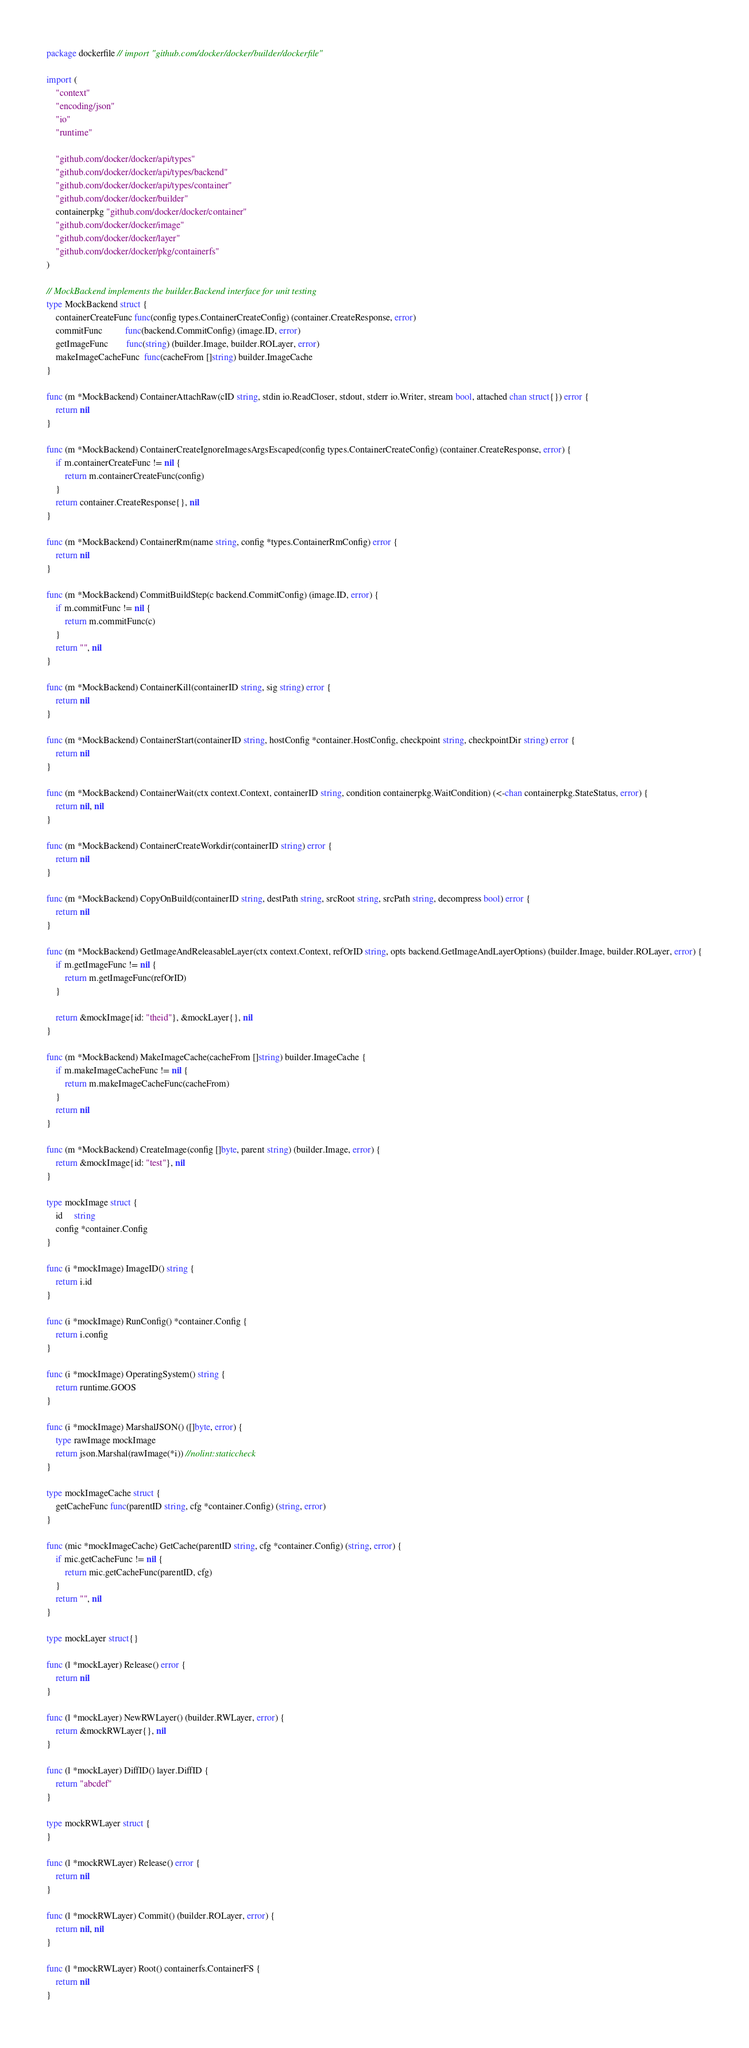<code> <loc_0><loc_0><loc_500><loc_500><_Go_>package dockerfile // import "github.com/docker/docker/builder/dockerfile"

import (
	"context"
	"encoding/json"
	"io"
	"runtime"

	"github.com/docker/docker/api/types"
	"github.com/docker/docker/api/types/backend"
	"github.com/docker/docker/api/types/container"
	"github.com/docker/docker/builder"
	containerpkg "github.com/docker/docker/container"
	"github.com/docker/docker/image"
	"github.com/docker/docker/layer"
	"github.com/docker/docker/pkg/containerfs"
)

// MockBackend implements the builder.Backend interface for unit testing
type MockBackend struct {
	containerCreateFunc func(config types.ContainerCreateConfig) (container.CreateResponse, error)
	commitFunc          func(backend.CommitConfig) (image.ID, error)
	getImageFunc        func(string) (builder.Image, builder.ROLayer, error)
	makeImageCacheFunc  func(cacheFrom []string) builder.ImageCache
}

func (m *MockBackend) ContainerAttachRaw(cID string, stdin io.ReadCloser, stdout, stderr io.Writer, stream bool, attached chan struct{}) error {
	return nil
}

func (m *MockBackend) ContainerCreateIgnoreImagesArgsEscaped(config types.ContainerCreateConfig) (container.CreateResponse, error) {
	if m.containerCreateFunc != nil {
		return m.containerCreateFunc(config)
	}
	return container.CreateResponse{}, nil
}

func (m *MockBackend) ContainerRm(name string, config *types.ContainerRmConfig) error {
	return nil
}

func (m *MockBackend) CommitBuildStep(c backend.CommitConfig) (image.ID, error) {
	if m.commitFunc != nil {
		return m.commitFunc(c)
	}
	return "", nil
}

func (m *MockBackend) ContainerKill(containerID string, sig string) error {
	return nil
}

func (m *MockBackend) ContainerStart(containerID string, hostConfig *container.HostConfig, checkpoint string, checkpointDir string) error {
	return nil
}

func (m *MockBackend) ContainerWait(ctx context.Context, containerID string, condition containerpkg.WaitCondition) (<-chan containerpkg.StateStatus, error) {
	return nil, nil
}

func (m *MockBackend) ContainerCreateWorkdir(containerID string) error {
	return nil
}

func (m *MockBackend) CopyOnBuild(containerID string, destPath string, srcRoot string, srcPath string, decompress bool) error {
	return nil
}

func (m *MockBackend) GetImageAndReleasableLayer(ctx context.Context, refOrID string, opts backend.GetImageAndLayerOptions) (builder.Image, builder.ROLayer, error) {
	if m.getImageFunc != nil {
		return m.getImageFunc(refOrID)
	}

	return &mockImage{id: "theid"}, &mockLayer{}, nil
}

func (m *MockBackend) MakeImageCache(cacheFrom []string) builder.ImageCache {
	if m.makeImageCacheFunc != nil {
		return m.makeImageCacheFunc(cacheFrom)
	}
	return nil
}

func (m *MockBackend) CreateImage(config []byte, parent string) (builder.Image, error) {
	return &mockImage{id: "test"}, nil
}

type mockImage struct {
	id     string
	config *container.Config
}

func (i *mockImage) ImageID() string {
	return i.id
}

func (i *mockImage) RunConfig() *container.Config {
	return i.config
}

func (i *mockImage) OperatingSystem() string {
	return runtime.GOOS
}

func (i *mockImage) MarshalJSON() ([]byte, error) {
	type rawImage mockImage
	return json.Marshal(rawImage(*i)) //nolint:staticcheck
}

type mockImageCache struct {
	getCacheFunc func(parentID string, cfg *container.Config) (string, error)
}

func (mic *mockImageCache) GetCache(parentID string, cfg *container.Config) (string, error) {
	if mic.getCacheFunc != nil {
		return mic.getCacheFunc(parentID, cfg)
	}
	return "", nil
}

type mockLayer struct{}

func (l *mockLayer) Release() error {
	return nil
}

func (l *mockLayer) NewRWLayer() (builder.RWLayer, error) {
	return &mockRWLayer{}, nil
}

func (l *mockLayer) DiffID() layer.DiffID {
	return "abcdef"
}

type mockRWLayer struct {
}

func (l *mockRWLayer) Release() error {
	return nil
}

func (l *mockRWLayer) Commit() (builder.ROLayer, error) {
	return nil, nil
}

func (l *mockRWLayer) Root() containerfs.ContainerFS {
	return nil
}
</code> 